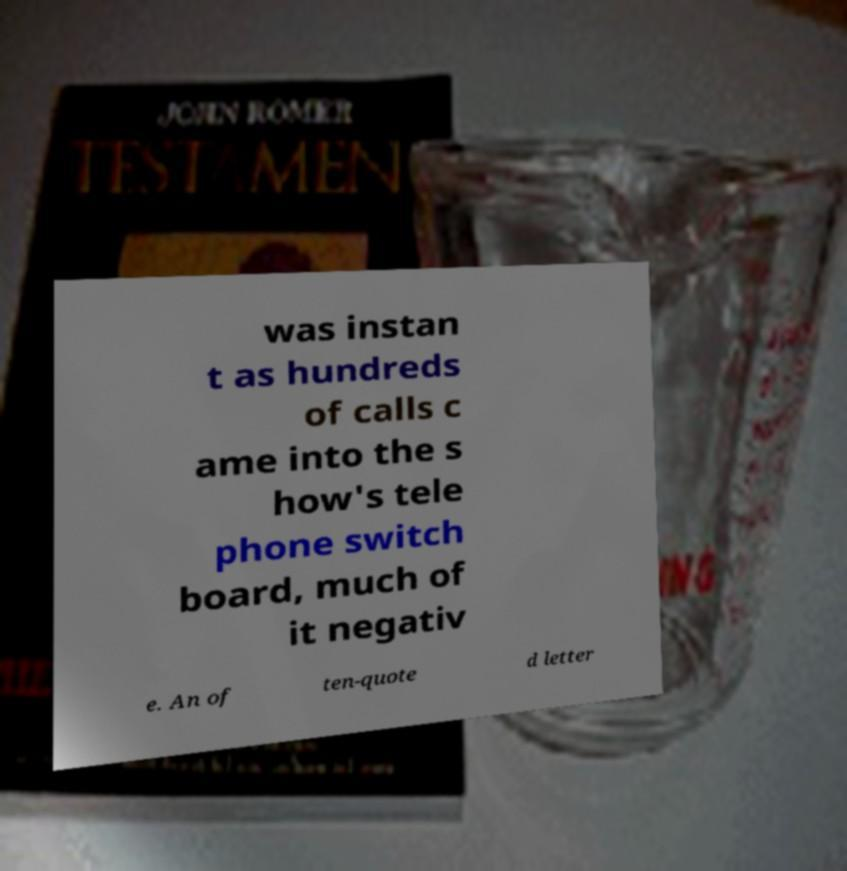There's text embedded in this image that I need extracted. Can you transcribe it verbatim? was instan t as hundreds of calls c ame into the s how's tele phone switch board, much of it negativ e. An of ten-quote d letter 